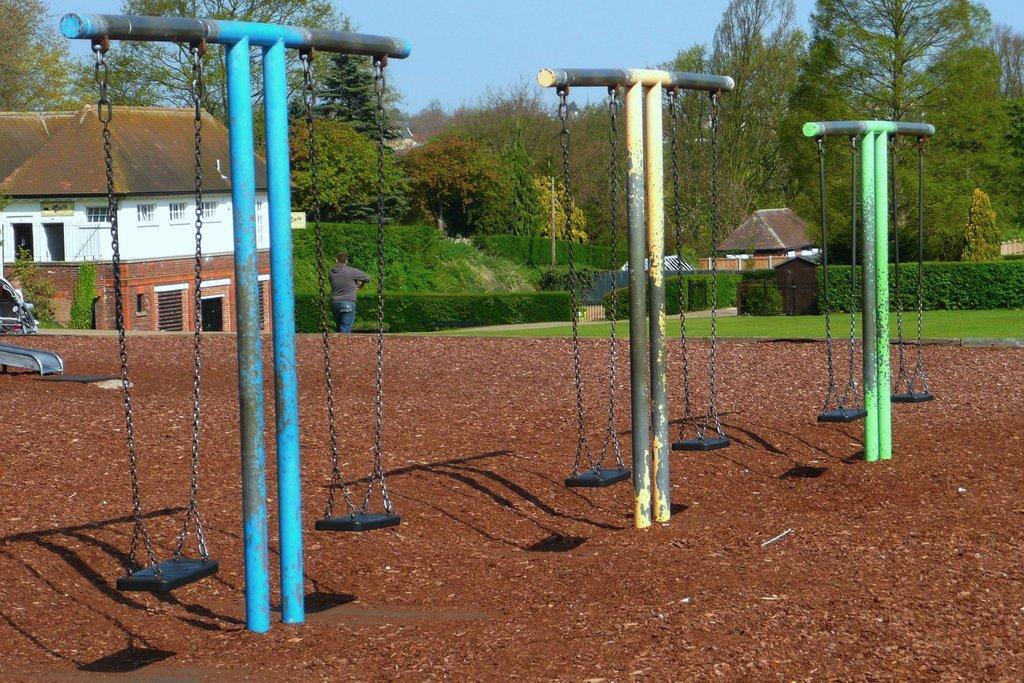In one or two sentences, can you explain what this image depicts? In the center of the image we can see poles, swings are there. In the background of the image we can see houses, bushes, trees, vehicle and man are there. At the top of the image we can see a sky. At the bottom of the image mud is there. In the middle of the image grass is there. 